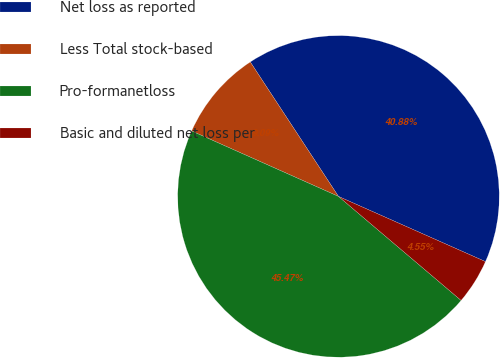<chart> <loc_0><loc_0><loc_500><loc_500><pie_chart><fcel>Net loss as reported<fcel>Less Total stock-based<fcel>Pro-formanetloss<fcel>Basic and diluted net loss per<nl><fcel>40.88%<fcel>9.09%<fcel>45.47%<fcel>4.55%<nl></chart> 